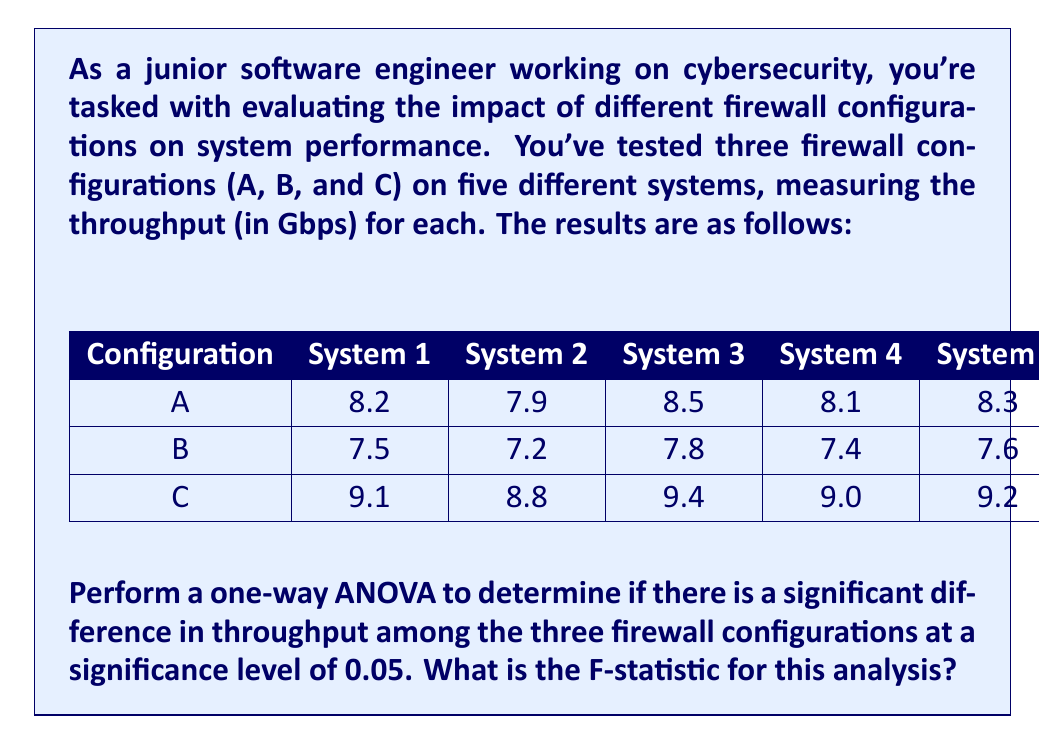Solve this math problem. To perform a one-way ANOVA, we'll follow these steps:

1) Calculate the mean for each group (configuration):
   A: $\bar{X}_A = \frac{8.2 + 7.9 + 8.5 + 8.1 + 8.3}{5} = 8.2$
   B: $\bar{X}_B = \frac{7.5 + 7.2 + 7.8 + 7.4 + 7.6}{5} = 7.5$
   C: $\bar{X}_C = \frac{9.1 + 8.8 + 9.4 + 9.0 + 9.2}{5} = 9.1$

2) Calculate the grand mean:
   $\bar{X} = \frac{8.2 + 7.5 + 9.1}{3} = 8.267$

3) Calculate SSB (Sum of Squares Between groups):
   $$SSB = 5[(8.2 - 8.267)^2 + (7.5 - 8.267)^2 + (9.1 - 8.267)^2] = 8.134$$

4) Calculate SSW (Sum of Squares Within groups):
   $$SSW = \sum_{i=1}^{3}\sum_{j=1}^{5}(X_{ij} - \bar{X_i})^2$$
   For A: $(8.2-8.2)^2 + (7.9-8.2)^2 + (8.5-8.2)^2 + (8.1-8.2)^2 + (8.3-8.2)^2 = 0.24$
   For B: $(7.5-7.5)^2 + (7.2-7.5)^2 + (7.8-7.5)^2 + (7.4-7.5)^2 + (7.6-7.5)^2 = 0.24$
   For C: $(9.1-9.1)^2 + (8.8-9.1)^2 + (9.4-9.1)^2 + (9.0-9.1)^2 + (9.2-9.1)^2 = 0.24$
   $$SSW = 0.24 + 0.24 + 0.24 = 0.72$$

5) Calculate degrees of freedom:
   dfB (between groups) = 3 - 1 = 2
   dfW (within groups) = 3(5 - 1) = 12

6) Calculate Mean Square Between (MSB) and Mean Square Within (MSW):
   $$MSB = \frac{SSB}{dfB} = \frac{8.134}{2} = 4.067$$
   $$MSW = \frac{SSW}{dfW} = \frac{0.72}{12} = 0.06$$

7) Calculate the F-statistic:
   $$F = \frac{MSB}{MSW} = \frac{4.067}{0.06} = 67.783$$
Answer: 67.783 